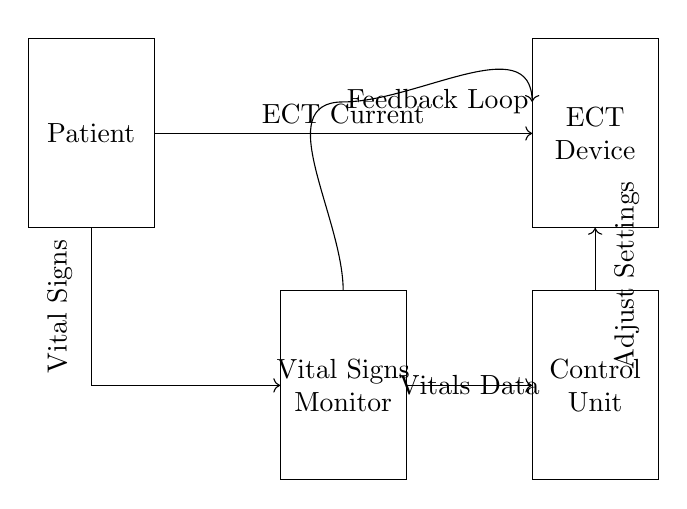What is the primary function of the Control Unit? The Control Unit is responsible for adjusting settings based on the feedback from the Vital Signs Monitor, thereby regulating ECT conditions according to patient vitals.
Answer: Adjusting settings What do the arrows indicate in the circuit diagram? The arrows represent the direction of signal or current flow between the components, showing how information and power are transmitted across the system.
Answer: Direction of flow What component is situated directly below the ECT Device? The Vital Signs Monitor is positioned directly below the ECT Device, indicating its role in monitoring patient vitals during ECT.
Answer: Vital Signs Monitor How does the feedback loop operate? The feedback loop collects data from the Vital Signs Monitor and sends it back to the Control Unit to inform adjustments needed for the ECT conditions, creating a continuous monitoring system.
Answer: Continuous monitoring What type of information is transmitted from the Vital Signs Monitor to the Control Unit? Vital data specifically relating to the patient's physiological state, which is essential for the Control Unit to make informed adjustments to the ECT Device.
Answer: Vitals Data What does the label "Adjust Settings" refer to in the circuit? "Adjust Settings" indicates the process by which the Control Unit modifies ECT device parameters based on real-time feedback from the patient’s vital signs.
Answer: Modifying parameters 